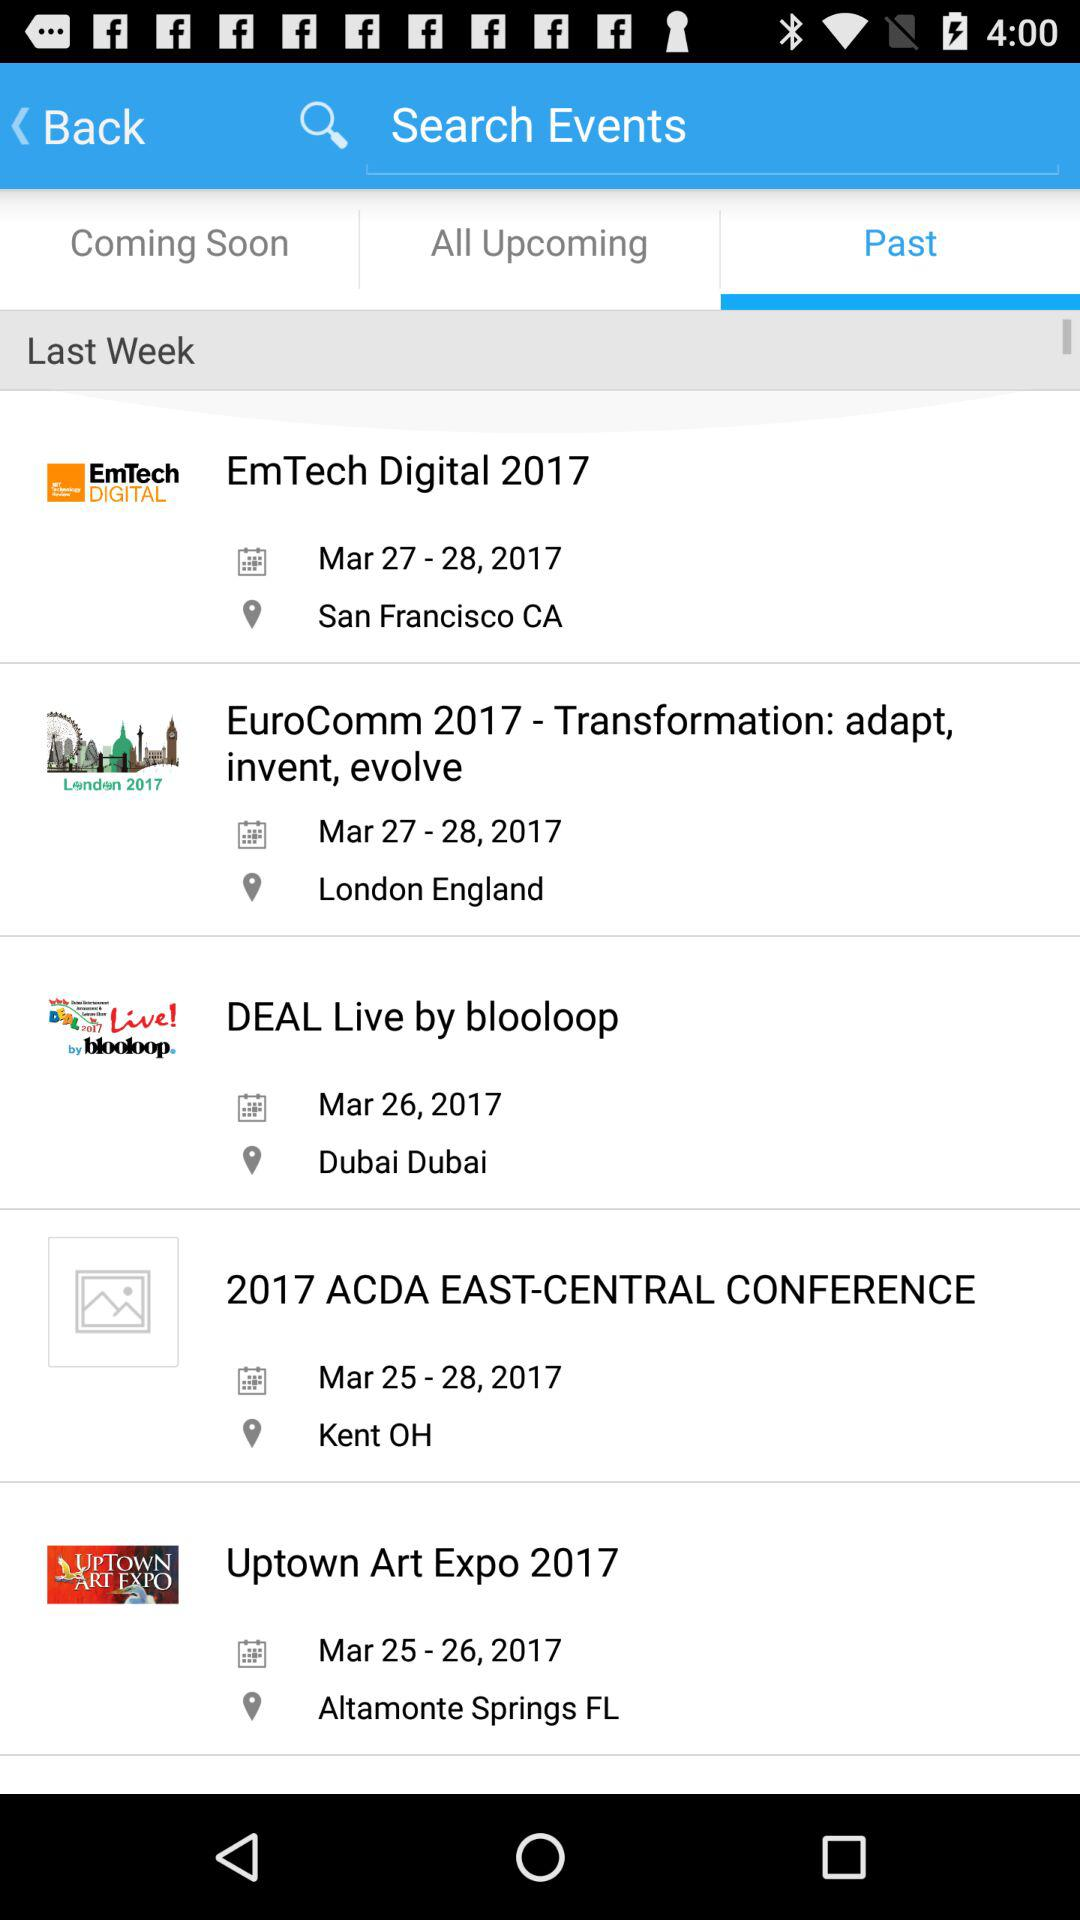For which date is "DEAL Live by blooloop" scheduled? "DEAL Live by blooloop" is scheduled for March 26, 2017. 